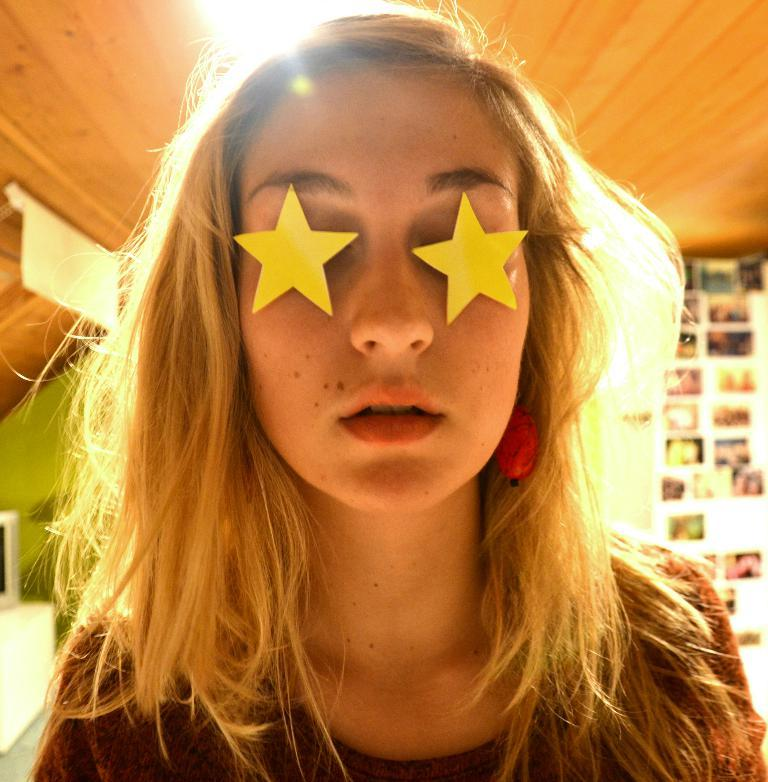Who is present in the image? There is a woman in the image. What is unique about the woman's appearance? The woman has paper stars on her eyes. Can you describe the background of the image? There are objects in the background of the image. What type of respect is being shown during the meeting in the image? There is no meeting present in the image, and therefore no such interaction can be observed. Can you tell me how many crows are visible in the image? There are no crows present in the image. 